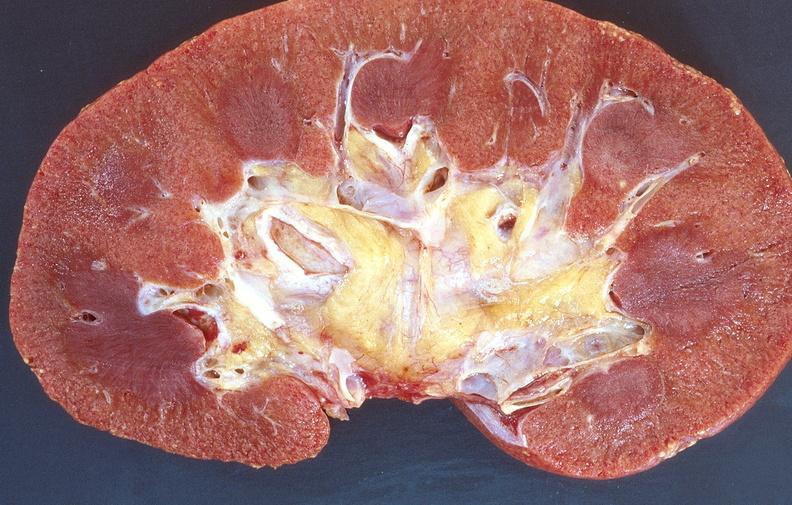what does this image show?
Answer the question using a single word or phrase. Normal kidney 